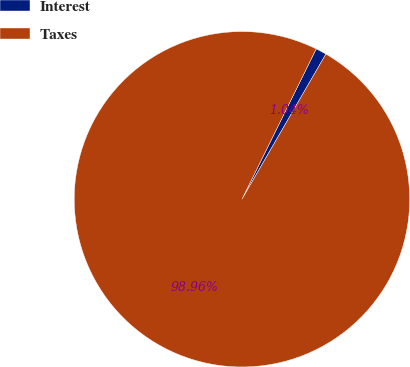<chart> <loc_0><loc_0><loc_500><loc_500><pie_chart><fcel>Interest<fcel>Taxes<nl><fcel>1.04%<fcel>98.96%<nl></chart> 